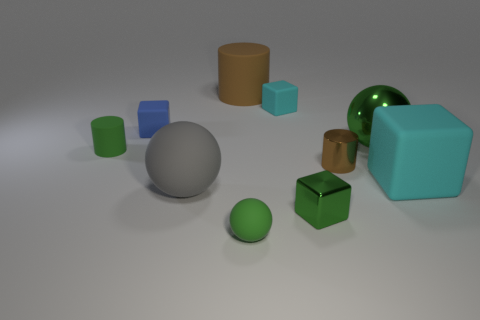There is a tiny metallic thing that is the same color as the small matte sphere; what is its shape?
Your answer should be compact. Cube. Are there any big objects that have the same shape as the tiny brown object?
Offer a very short reply. Yes. How many rubber spheres are there?
Your answer should be very brief. 2. What is the shape of the big gray rubber object?
Your answer should be very brief. Sphere. How many purple blocks are the same size as the gray ball?
Give a very brief answer. 0. Does the tiny brown thing have the same shape as the big brown rubber object?
Your answer should be very brief. Yes. The large rubber object that is to the right of the ball that is in front of the green shiny block is what color?
Provide a succinct answer. Cyan. What size is the rubber thing that is both left of the tiny matte ball and in front of the tiny brown metallic object?
Provide a short and direct response. Large. Are there any other things of the same color as the metal cylinder?
Your response must be concise. Yes. There is a big brown object that is made of the same material as the blue object; what shape is it?
Give a very brief answer. Cylinder. 